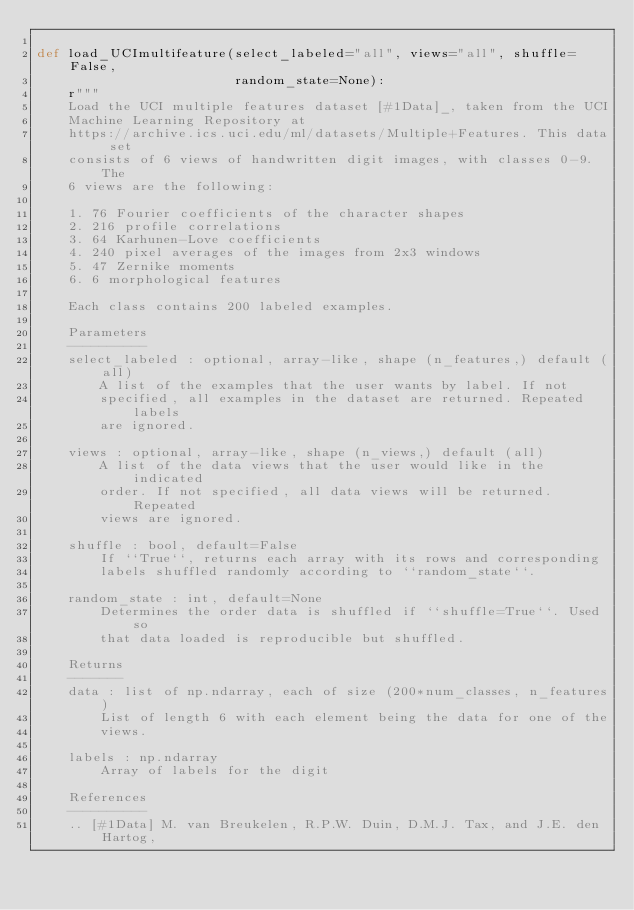Convert code to text. <code><loc_0><loc_0><loc_500><loc_500><_Python_>
def load_UCImultifeature(select_labeled="all", views="all", shuffle=False,
                         random_state=None):
    r"""
    Load the UCI multiple features dataset [#1Data]_, taken from the UCI
    Machine Learning Repository at
    https://archive.ics.uci.edu/ml/datasets/Multiple+Features. This data set
    consists of 6 views of handwritten digit images, with classes 0-9. The
    6 views are the following:

    1. 76 Fourier coefficients of the character shapes
    2. 216 profile correlations
    3. 64 Karhunen-Love coefficients
    4. 240 pixel averages of the images from 2x3 windows
    5. 47 Zernike moments
    6. 6 morphological features

    Each class contains 200 labeled examples.

    Parameters
    ----------
    select_labeled : optional, array-like, shape (n_features,) default (all)
        A list of the examples that the user wants by label. If not
        specified, all examples in the dataset are returned. Repeated labels
        are ignored.

    views : optional, array-like, shape (n_views,) default (all)
        A list of the data views that the user would like in the indicated
        order. If not specified, all data views will be returned. Repeated
        views are ignored.

    shuffle : bool, default=False
        If ``True``, returns each array with its rows and corresponding
        labels shuffled randomly according to ``random_state``.

    random_state : int, default=None
        Determines the order data is shuffled if ``shuffle=True``. Used so
        that data loaded is reproducible but shuffled.

    Returns
    -------
    data : list of np.ndarray, each of size (200*num_classes, n_features)
        List of length 6 with each element being the data for one of the
        views.

    labels : np.ndarray
        Array of labels for the digit

    References
    ----------
    .. [#1Data] M. van Breukelen, R.P.W. Duin, D.M.J. Tax, and J.E. den Hartog,</code> 